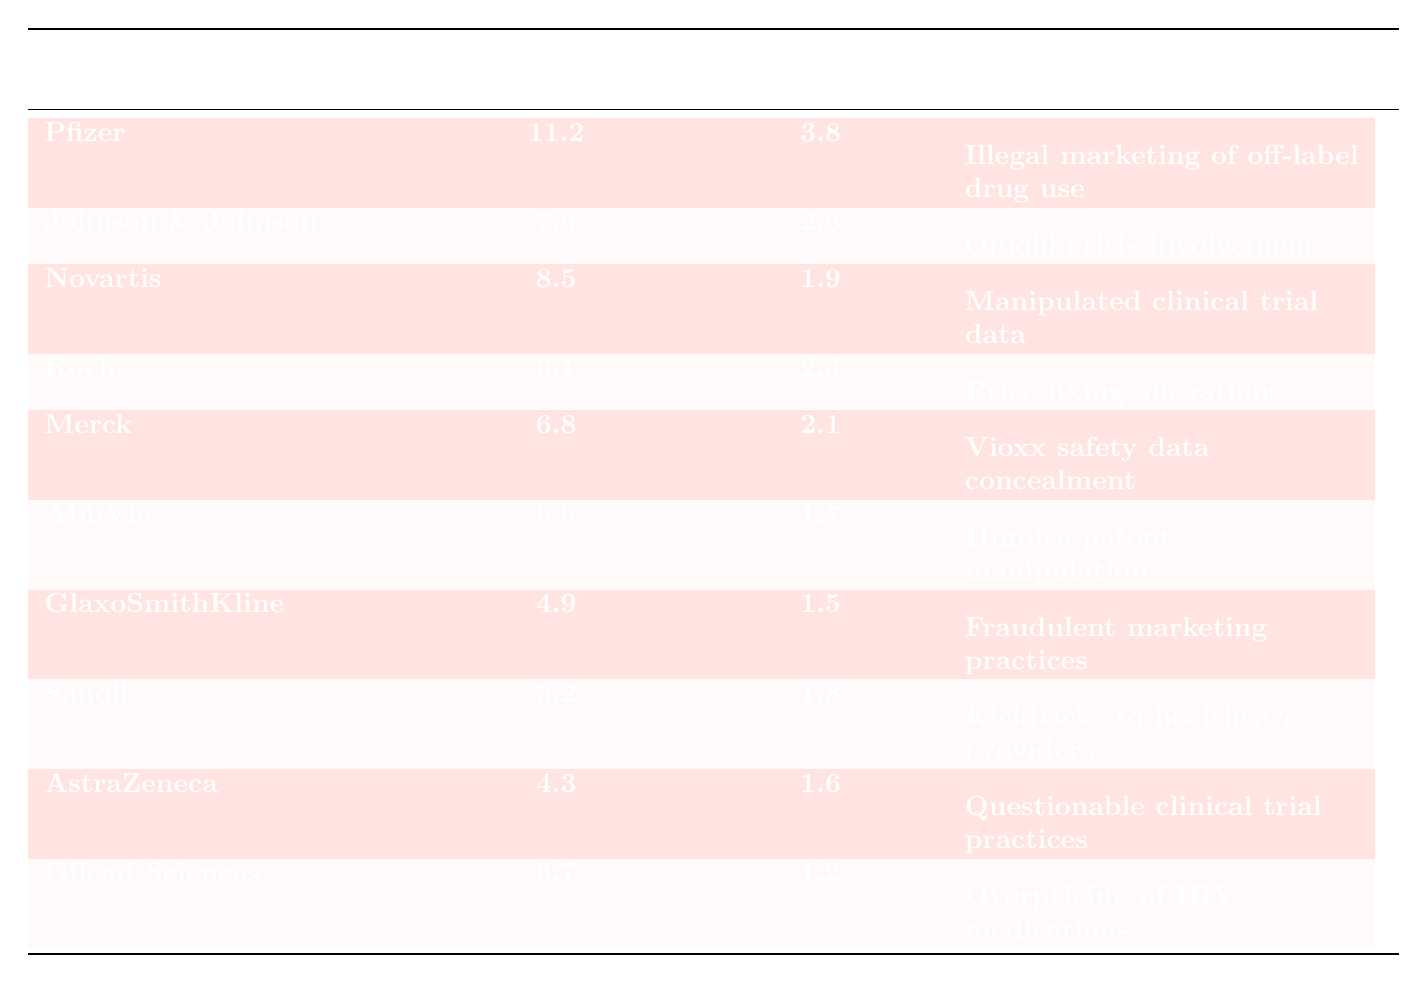What are the lobbying expenses of Pfizer? Looking at the table, the annual lobbying expenses for Pfizer are listed in the second column. The value given is 11.2 million dollars.
Answer: 11.2 million dollars Which pharmaceutical company has the highest political donations? The table rankings show the political donations for each company in the third column. By comparing these values, Pfizer has the highest with 3.8 million dollars.
Answer: Pfizer What is the notable ethical controversy associated with Merck? In the last column of the table, the controversy listed for Merck is specifically about the concealment of safety data regarding Vioxx.
Answer: Vioxx safety data concealment What is the sum of the annual lobbying expenses for Johnson & Johnson and Gilead Sciences? From the table, Johnson & Johnson has lobbying expenses of 7.9 million dollars, and Gilead Sciences has 3.7 million dollars. Adding these together: 7.9 + 3.7 = 11.6 million dollars.
Answer: 11.6 million dollars Are there any companies with political donations less than 1.5 million dollars? Examining the third column for political donations, Gilead Sciences has the lowest at 1.2 million dollars, which is less than 1.5 million dollars. Thus, the answer is yes.
Answer: Yes Which company has both the highest lobbying expenses and notable ethical controversy related to price fixing? Upon reviewing the table, Roche has the highest lobbying expenses of 9.1 million dollars, and the ethical controversy concerning them involves price fixing allegations.
Answer: Roche What is the average political donation among the top five pharmaceutical companies listed? The political donations for the top five companies (Pfizer, Johnson & Johnson, Novartis, Roche, and Merck) are 3.8, 2.6, 1.9, 2.3, and 2.1 million dollars respectively. The sum of these values is 12.7 million dollars. Dividing 12.7 by 5 gives an average of 2.54 million dollars.
Answer: 2.54 million dollars Which company has a notable ethical controversy related to manipulated clinical trial data? Referring to the notable ethical controversy column, Novartis is associated with manipulated clinical trial data.
Answer: Novartis Is there any company that has spent more than 10 million dollars on annual lobbying? By inspecting the annual lobbying expenses column, only Pfizer exceeds 10 million dollars, spending 11.2 million dollars. Therefore, the answer is yes.
Answer: Yes What is the difference in political donations between Novartis and GlaxoSmithKline? Novartis has political donations of 1.9 million dollars while GlaxoSmithKline has 1.5 million dollars. The difference is 1.9 - 1.5 = 0.4 million dollars.
Answer: 0.4 million dollars 